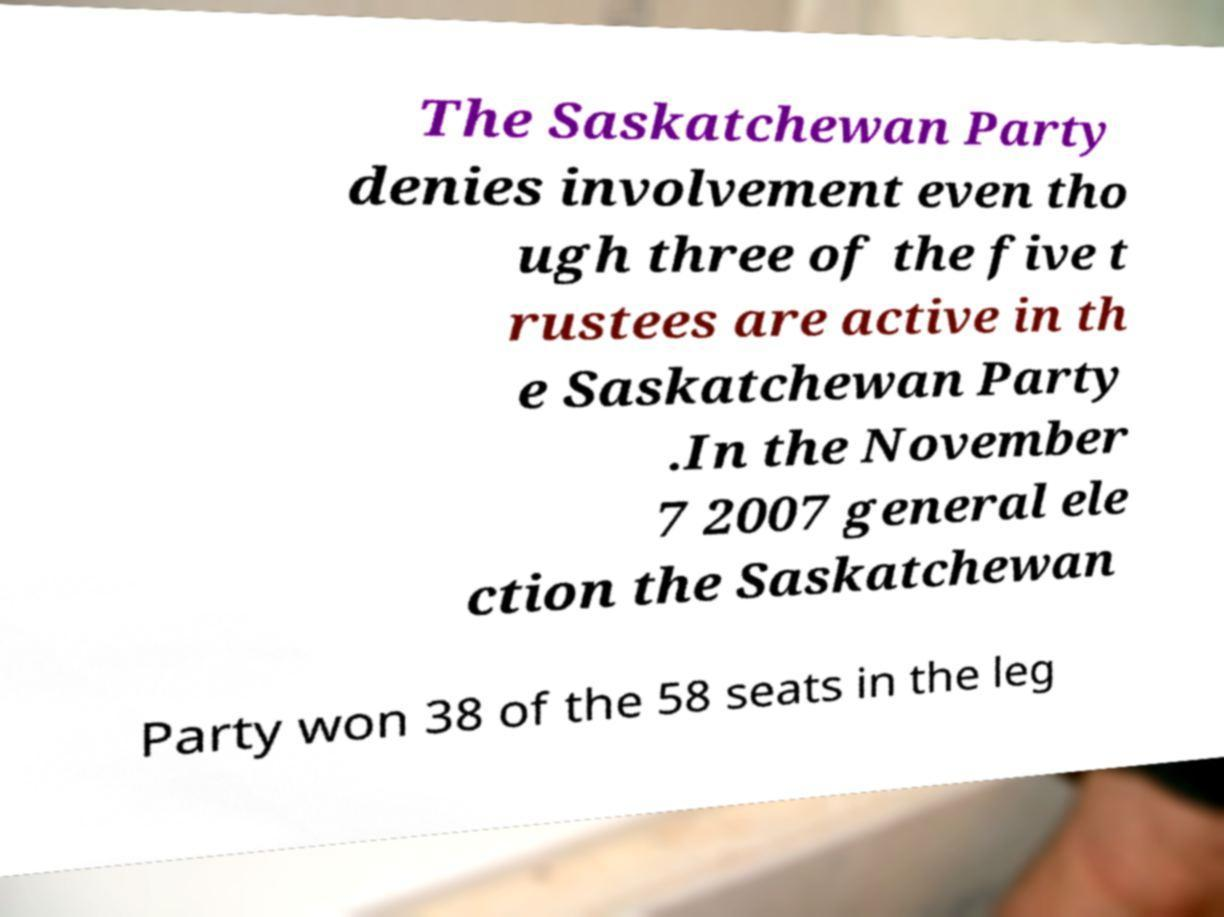There's text embedded in this image that I need extracted. Can you transcribe it verbatim? The Saskatchewan Party denies involvement even tho ugh three of the five t rustees are active in th e Saskatchewan Party .In the November 7 2007 general ele ction the Saskatchewan Party won 38 of the 58 seats in the leg 